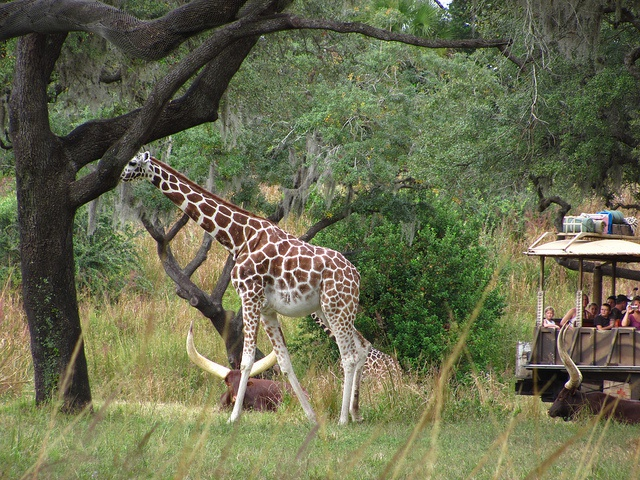Describe the objects in this image and their specific colors. I can see giraffe in black, darkgray, lightgray, gray, and maroon tones, truck in black and gray tones, cow in black, tan, brown, gray, and ivory tones, giraffe in black, tan, gray, and olive tones, and suitcase in black, darkgray, lightgray, and gray tones in this image. 